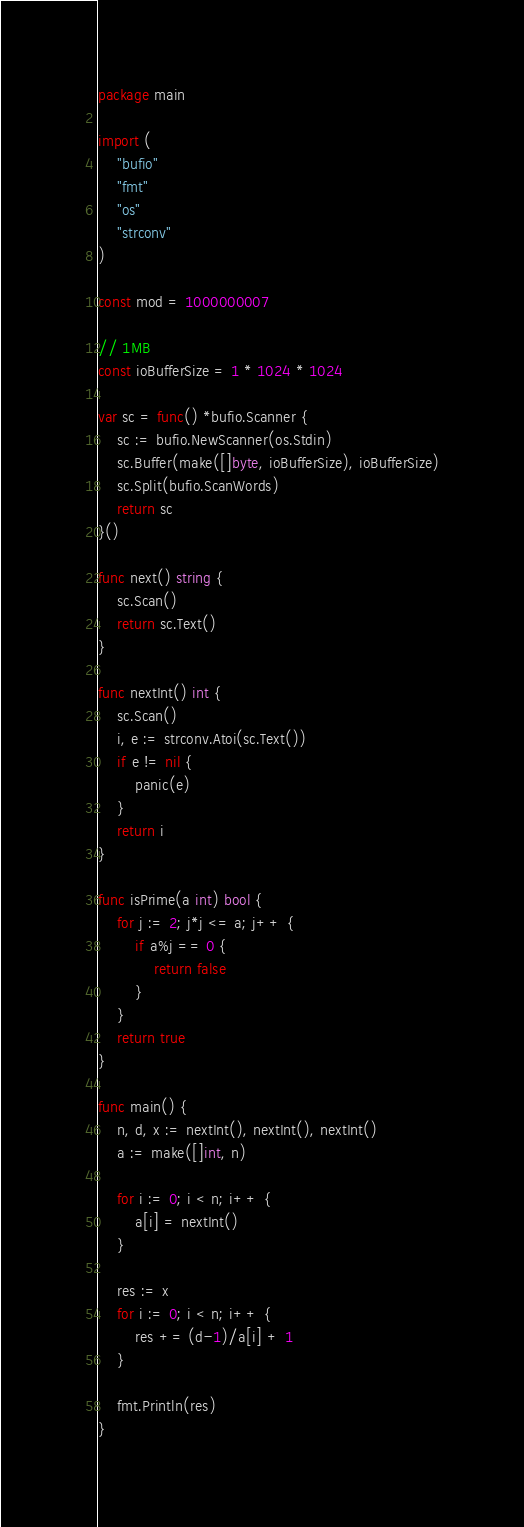Convert code to text. <code><loc_0><loc_0><loc_500><loc_500><_Go_>package main

import (
	"bufio"
	"fmt"
	"os"
	"strconv"
)

const mod = 1000000007

// 1MB
const ioBufferSize = 1 * 1024 * 1024

var sc = func() *bufio.Scanner {
	sc := bufio.NewScanner(os.Stdin)
	sc.Buffer(make([]byte, ioBufferSize), ioBufferSize)
	sc.Split(bufio.ScanWords)
	return sc
}()

func next() string {
	sc.Scan()
	return sc.Text()
}

func nextInt() int {
	sc.Scan()
	i, e := strconv.Atoi(sc.Text())
	if e != nil {
		panic(e)
	}
	return i
}

func isPrime(a int) bool {
	for j := 2; j*j <= a; j++ {
		if a%j == 0 {
			return false
		}
	}
	return true
}

func main() {
	n, d, x := nextInt(), nextInt(), nextInt()
	a := make([]int, n)

	for i := 0; i < n; i++ {
		a[i] = nextInt()
	}

	res := x
	for i := 0; i < n; i++ {
		res += (d-1)/a[i] + 1
	}

	fmt.Println(res)
}
</code> 